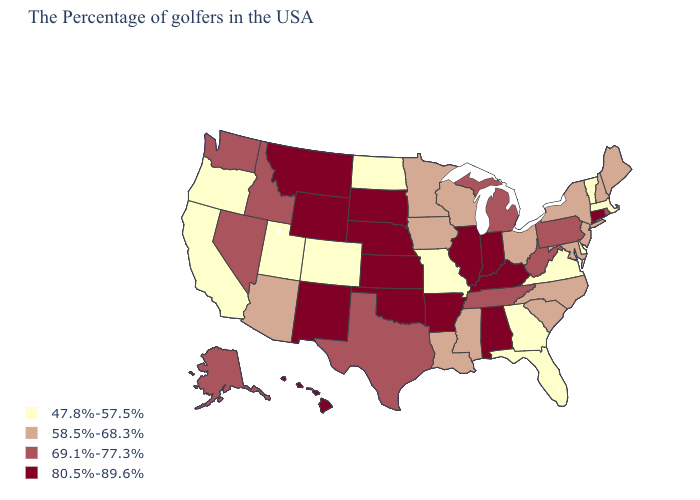Among the states that border New Jersey , does Pennsylvania have the lowest value?
Give a very brief answer. No. What is the highest value in the West ?
Concise answer only. 80.5%-89.6%. Name the states that have a value in the range 47.8%-57.5%?
Write a very short answer. Massachusetts, Vermont, Delaware, Virginia, Florida, Georgia, Missouri, North Dakota, Colorado, Utah, California, Oregon. What is the value of New Mexico?
Quick response, please. 80.5%-89.6%. Which states have the lowest value in the MidWest?
Answer briefly. Missouri, North Dakota. Does Rhode Island have the same value as Idaho?
Keep it brief. Yes. Does Tennessee have the highest value in the USA?
Short answer required. No. What is the value of Tennessee?
Keep it brief. 69.1%-77.3%. Name the states that have a value in the range 58.5%-68.3%?
Write a very short answer. Maine, New Hampshire, New York, New Jersey, Maryland, North Carolina, South Carolina, Ohio, Wisconsin, Mississippi, Louisiana, Minnesota, Iowa, Arizona. What is the lowest value in the USA?
Quick response, please. 47.8%-57.5%. What is the value of Tennessee?
Short answer required. 69.1%-77.3%. What is the value of Louisiana?
Give a very brief answer. 58.5%-68.3%. What is the lowest value in the USA?
Answer briefly. 47.8%-57.5%. Name the states that have a value in the range 80.5%-89.6%?
Give a very brief answer. Connecticut, Kentucky, Indiana, Alabama, Illinois, Arkansas, Kansas, Nebraska, Oklahoma, South Dakota, Wyoming, New Mexico, Montana, Hawaii. Does Delaware have the lowest value in the USA?
Write a very short answer. Yes. 